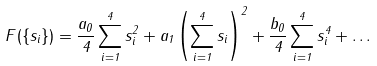<formula> <loc_0><loc_0><loc_500><loc_500>F ( \{ { s } _ { i } \} ) = \frac { a _ { 0 } } { 4 } \sum _ { i = 1 } ^ { 4 } s _ { i } ^ { 2 } + a _ { 1 } \left ( \sum _ { i = 1 } ^ { 4 } { s } _ { i } \right ) ^ { 2 } + \frac { b _ { 0 } } { 4 } \sum _ { i = 1 } ^ { 4 } s _ { i } ^ { 4 } + \dots</formula> 